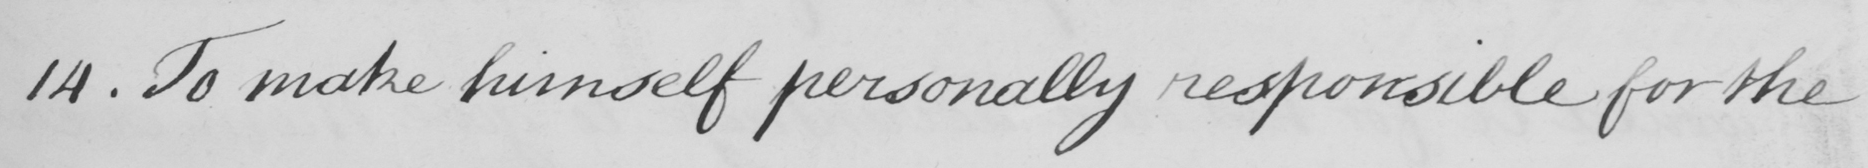What text is written in this handwritten line? 14 . To make himself personally responsible for the 